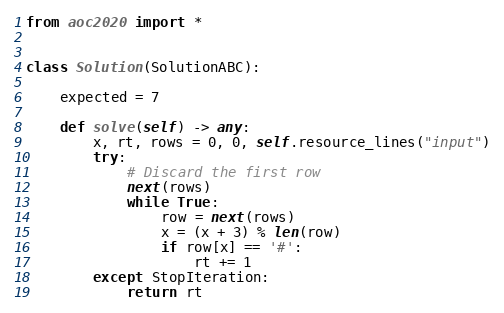<code> <loc_0><loc_0><loc_500><loc_500><_Python_>from aoc2020 import *


class Solution(SolutionABC):

    expected = 7

    def solve(self) -> any:
        x, rt, rows = 0, 0, self.resource_lines("input")
        try:
            # Discard the first row
            next(rows)
            while True:
                row = next(rows)
                x = (x + 3) % len(row)
                if row[x] == '#':
                    rt += 1
        except StopIteration:
            return rt
</code> 